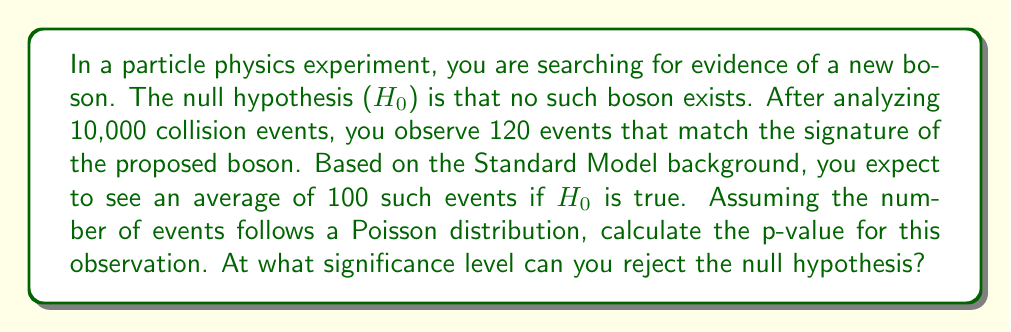Show me your answer to this math problem. To solve this problem, we'll follow these steps:

1) First, we need to understand the Poisson distribution. The probability of observing $k$ events when the mean is $\lambda$ is given by:

   $$P(X = k) = \frac{e^{-\lambda}\lambda^k}{k!}$$

2) In this case, $\lambda = 100$ (expected events under $H_0$) and $k = 120$ (observed events).

3) The p-value is the probability of observing a result at least as extreme as the one actually observed, assuming $H_0$ is true. For a Poisson distribution, this means the probability of observing 120 or more events:

   $$p = P(X \geq 120) = 1 - P(X < 120) = 1 - \sum_{k=0}^{119} \frac{e^{-100}100^k}{k!}$$

4) This sum is difficult to calculate by hand, so we typically use statistical software or tables. Using such a tool, we find:

   $$p \approx 0.0226$$

5) To interpret the significance level, we compare this p-value to common thresholds:
   - p < 0.05: Significant at the 5% level (2σ)
   - p < 0.01: Significant at the 1% level (2.6σ)
   - p < 0.001: Significant at the 0.1% level (3σ)

6) Our p-value (0.0226) is less than 0.05 but greater than 0.01.

Therefore, we can reject the null hypothesis at the 5% significance level (2σ), but not at the 1% level.
Answer: Reject $H_0$ at 5% significance level (2σ) 